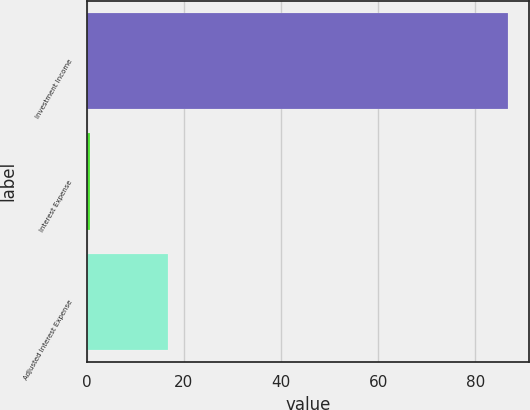Convert chart to OTSL. <chart><loc_0><loc_0><loc_500><loc_500><bar_chart><fcel>Investment Income<fcel>Interest Expense<fcel>Adjusted Interest Expense<nl><fcel>86.7<fcel>0.7<fcel>16.7<nl></chart> 